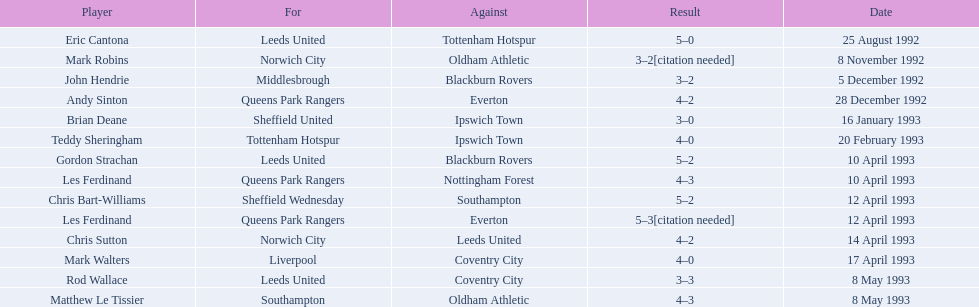Specify the exclusive french player. Eric Cantona. 